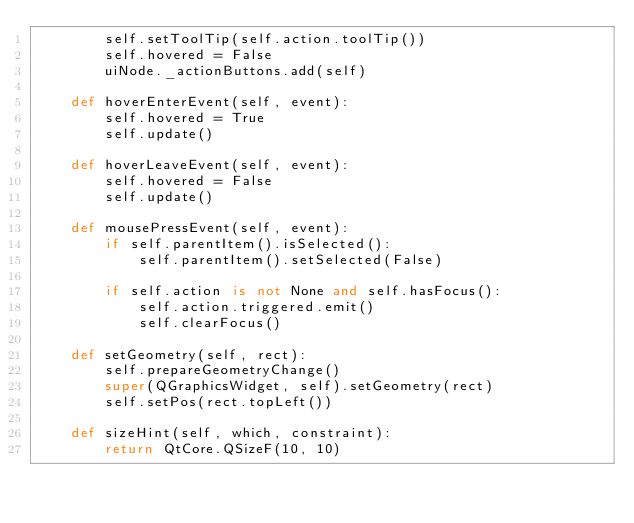<code> <loc_0><loc_0><loc_500><loc_500><_Python_>        self.setToolTip(self.action.toolTip())
        self.hovered = False
        uiNode._actionButtons.add(self)

    def hoverEnterEvent(self, event):
        self.hovered = True
        self.update()

    def hoverLeaveEvent(self, event):
        self.hovered = False
        self.update()

    def mousePressEvent(self, event):
        if self.parentItem().isSelected():
            self.parentItem().setSelected(False)

        if self.action is not None and self.hasFocus():
            self.action.triggered.emit()
            self.clearFocus()

    def setGeometry(self, rect):
        self.prepareGeometryChange()
        super(QGraphicsWidget, self).setGeometry(rect)
        self.setPos(rect.topLeft())

    def sizeHint(self, which, constraint):
        return QtCore.QSizeF(10, 10)
</code> 